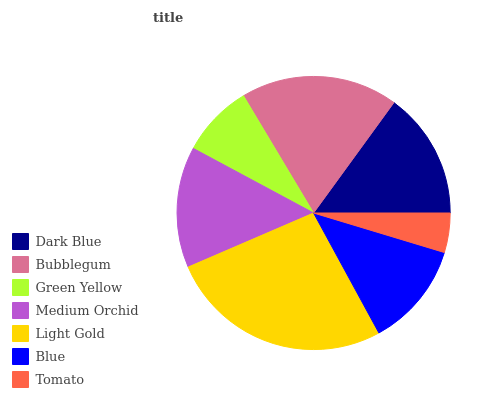Is Tomato the minimum?
Answer yes or no. Yes. Is Light Gold the maximum?
Answer yes or no. Yes. Is Bubblegum the minimum?
Answer yes or no. No. Is Bubblegum the maximum?
Answer yes or no. No. Is Bubblegum greater than Dark Blue?
Answer yes or no. Yes. Is Dark Blue less than Bubblegum?
Answer yes or no. Yes. Is Dark Blue greater than Bubblegum?
Answer yes or no. No. Is Bubblegum less than Dark Blue?
Answer yes or no. No. Is Medium Orchid the high median?
Answer yes or no. Yes. Is Medium Orchid the low median?
Answer yes or no. Yes. Is Light Gold the high median?
Answer yes or no. No. Is Dark Blue the low median?
Answer yes or no. No. 